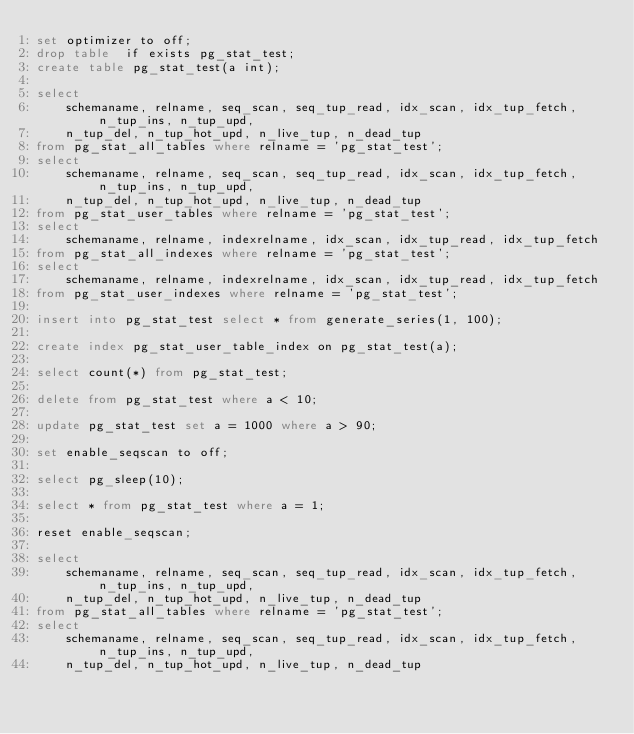Convert code to text. <code><loc_0><loc_0><loc_500><loc_500><_SQL_>set optimizer to off;
drop table  if exists pg_stat_test;
create table pg_stat_test(a int);

select
    schemaname, relname, seq_scan, seq_tup_read, idx_scan, idx_tup_fetch, n_tup_ins, n_tup_upd,
    n_tup_del, n_tup_hot_upd, n_live_tup, n_dead_tup
from pg_stat_all_tables where relname = 'pg_stat_test';
select
    schemaname, relname, seq_scan, seq_tup_read, idx_scan, idx_tup_fetch, n_tup_ins, n_tup_upd,
    n_tup_del, n_tup_hot_upd, n_live_tup, n_dead_tup
from pg_stat_user_tables where relname = 'pg_stat_test';
select
    schemaname, relname, indexrelname, idx_scan, idx_tup_read, idx_tup_fetch
from pg_stat_all_indexes where relname = 'pg_stat_test';
select
    schemaname, relname, indexrelname, idx_scan, idx_tup_read, idx_tup_fetch
from pg_stat_user_indexes where relname = 'pg_stat_test';

insert into pg_stat_test select * from generate_series(1, 100);

create index pg_stat_user_table_index on pg_stat_test(a);

select count(*) from pg_stat_test;

delete from pg_stat_test where a < 10;

update pg_stat_test set a = 1000 where a > 90;

set enable_seqscan to off;

select pg_sleep(10);

select * from pg_stat_test where a = 1;

reset enable_seqscan;

select
    schemaname, relname, seq_scan, seq_tup_read, idx_scan, idx_tup_fetch, n_tup_ins, n_tup_upd,
    n_tup_del, n_tup_hot_upd, n_live_tup, n_dead_tup
from pg_stat_all_tables where relname = 'pg_stat_test';
select
    schemaname, relname, seq_scan, seq_tup_read, idx_scan, idx_tup_fetch, n_tup_ins, n_tup_upd,
    n_tup_del, n_tup_hot_upd, n_live_tup, n_dead_tup</code> 